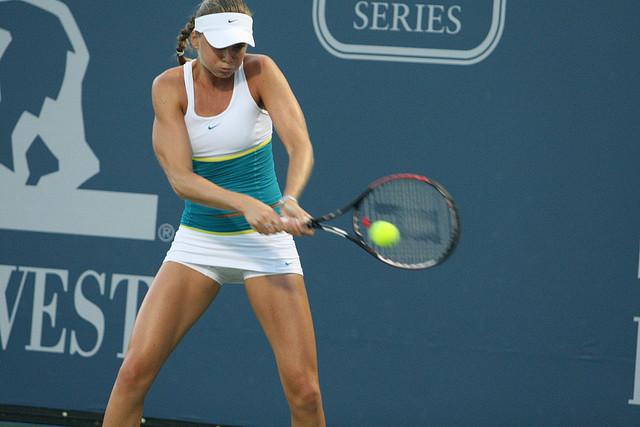What is this woman doing?
Answer briefly. Tennis. Is this woman out of shape?
Concise answer only. No. What does the symbol on the woman's shirt mean?
Give a very brief answer. Nike. 